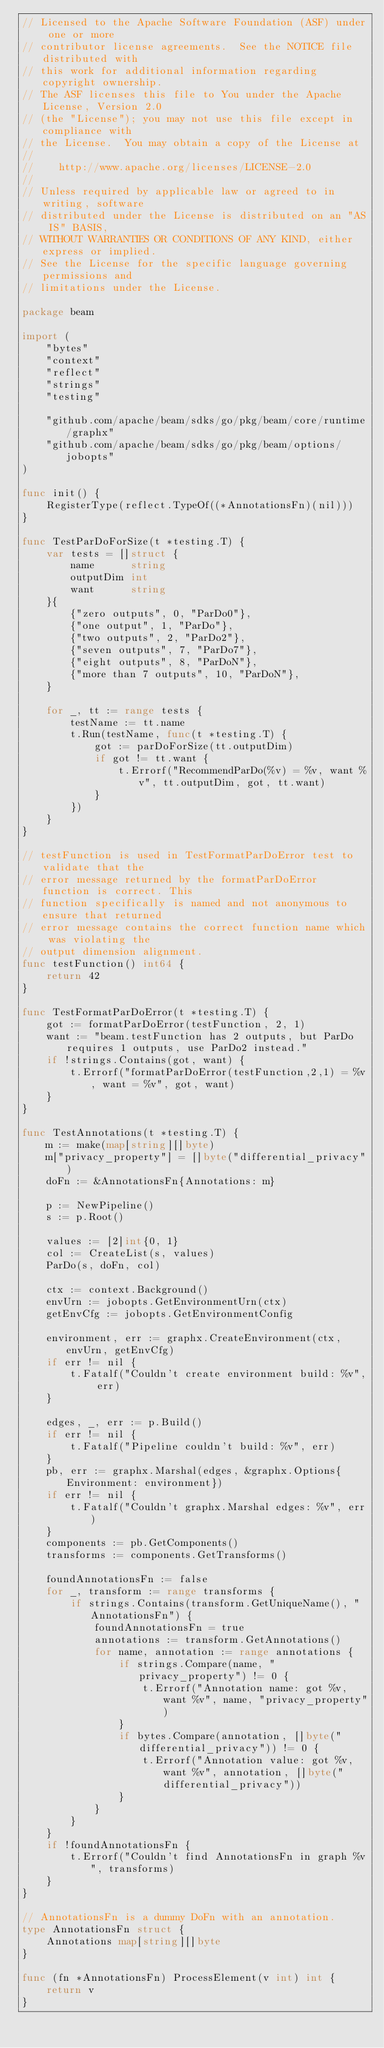<code> <loc_0><loc_0><loc_500><loc_500><_Go_>// Licensed to the Apache Software Foundation (ASF) under one or more
// contributor license agreements.  See the NOTICE file distributed with
// this work for additional information regarding copyright ownership.
// The ASF licenses this file to You under the Apache License, Version 2.0
// (the "License"); you may not use this file except in compliance with
// the License.  You may obtain a copy of the License at
//
//    http://www.apache.org/licenses/LICENSE-2.0
//
// Unless required by applicable law or agreed to in writing, software
// distributed under the License is distributed on an "AS IS" BASIS,
// WITHOUT WARRANTIES OR CONDITIONS OF ANY KIND, either express or implied.
// See the License for the specific language governing permissions and
// limitations under the License.

package beam

import (
	"bytes"
	"context"
	"reflect"
	"strings"
	"testing"

	"github.com/apache/beam/sdks/go/pkg/beam/core/runtime/graphx"
	"github.com/apache/beam/sdks/go/pkg/beam/options/jobopts"
)

func init() {
	RegisterType(reflect.TypeOf((*AnnotationsFn)(nil)))
}

func TestParDoForSize(t *testing.T) {
	var tests = []struct {
		name      string
		outputDim int
		want      string
	}{
		{"zero outputs", 0, "ParDo0"},
		{"one output", 1, "ParDo"},
		{"two outputs", 2, "ParDo2"},
		{"seven outputs", 7, "ParDo7"},
		{"eight outputs", 8, "ParDoN"},
		{"more than 7 outputs", 10, "ParDoN"},
	}

	for _, tt := range tests {
		testName := tt.name
		t.Run(testName, func(t *testing.T) {
			got := parDoForSize(tt.outputDim)
			if got != tt.want {
				t.Errorf("RecommendParDo(%v) = %v, want %v", tt.outputDim, got, tt.want)
			}
		})
	}
}

// testFunction is used in TestFormatParDoError test to validate that the
// error message returned by the formatParDoError function is correct. This
// function specifically is named and not anonymous to ensure that returned
// error message contains the correct function name which was violating the
// output dimension alignment.
func testFunction() int64 {
	return 42
}

func TestFormatParDoError(t *testing.T) {
	got := formatParDoError(testFunction, 2, 1)
	want := "beam.testFunction has 2 outputs, but ParDo requires 1 outputs, use ParDo2 instead."
	if !strings.Contains(got, want) {
		t.Errorf("formatParDoError(testFunction,2,1) = %v, want = %v", got, want)
	}
}

func TestAnnotations(t *testing.T) {
	m := make(map[string][]byte)
	m["privacy_property"] = []byte("differential_privacy")
	doFn := &AnnotationsFn{Annotations: m}

	p := NewPipeline()
	s := p.Root()

	values := [2]int{0, 1}
	col := CreateList(s, values)
	ParDo(s, doFn, col)

	ctx := context.Background()
	envUrn := jobopts.GetEnvironmentUrn(ctx)
	getEnvCfg := jobopts.GetEnvironmentConfig

	environment, err := graphx.CreateEnvironment(ctx, envUrn, getEnvCfg)
	if err != nil {
		t.Fatalf("Couldn't create environment build: %v", err)
	}

	edges, _, err := p.Build()
	if err != nil {
		t.Fatalf("Pipeline couldn't build: %v", err)
	}
	pb, err := graphx.Marshal(edges, &graphx.Options{Environment: environment})
	if err != nil {
		t.Fatalf("Couldn't graphx.Marshal edges: %v", err)
	}
	components := pb.GetComponents()
	transforms := components.GetTransforms()

	foundAnnotationsFn := false
	for _, transform := range transforms {
		if strings.Contains(transform.GetUniqueName(), "AnnotationsFn") {
			foundAnnotationsFn = true
			annotations := transform.GetAnnotations()
			for name, annotation := range annotations {
				if strings.Compare(name, "privacy_property") != 0 {
					t.Errorf("Annotation name: got %v, want %v", name, "privacy_property")
				}
				if bytes.Compare(annotation, []byte("differential_privacy")) != 0 {
					t.Errorf("Annotation value: got %v, want %v", annotation, []byte("differential_privacy"))
				}
			}
		}
	}
	if !foundAnnotationsFn {
		t.Errorf("Couldn't find AnnotationsFn in graph %v", transforms)
	}
}

// AnnotationsFn is a dummy DoFn with an annotation.
type AnnotationsFn struct {
	Annotations map[string][]byte
}

func (fn *AnnotationsFn) ProcessElement(v int) int {
	return v
}
</code> 